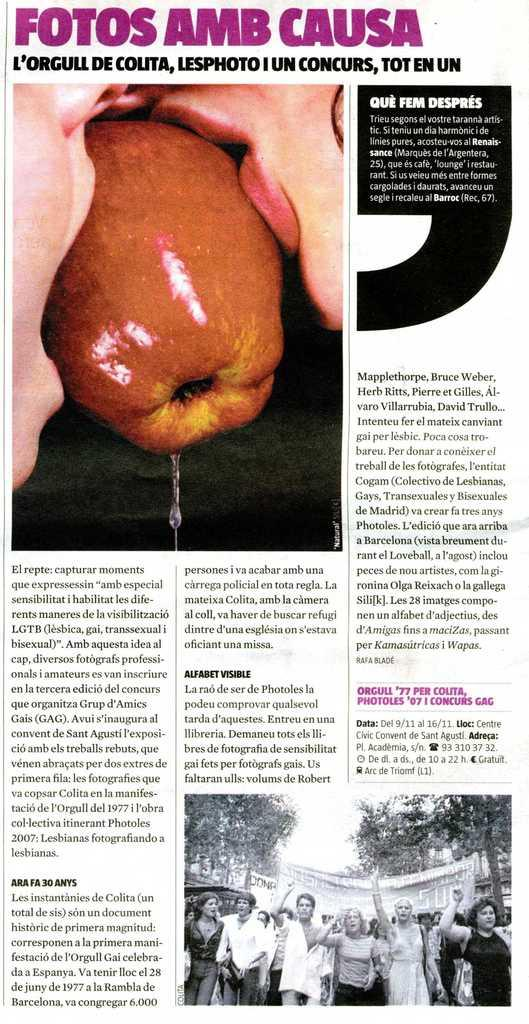<image>
Render a clear and concise summary of the photo. a paper that has the word fotos on it 